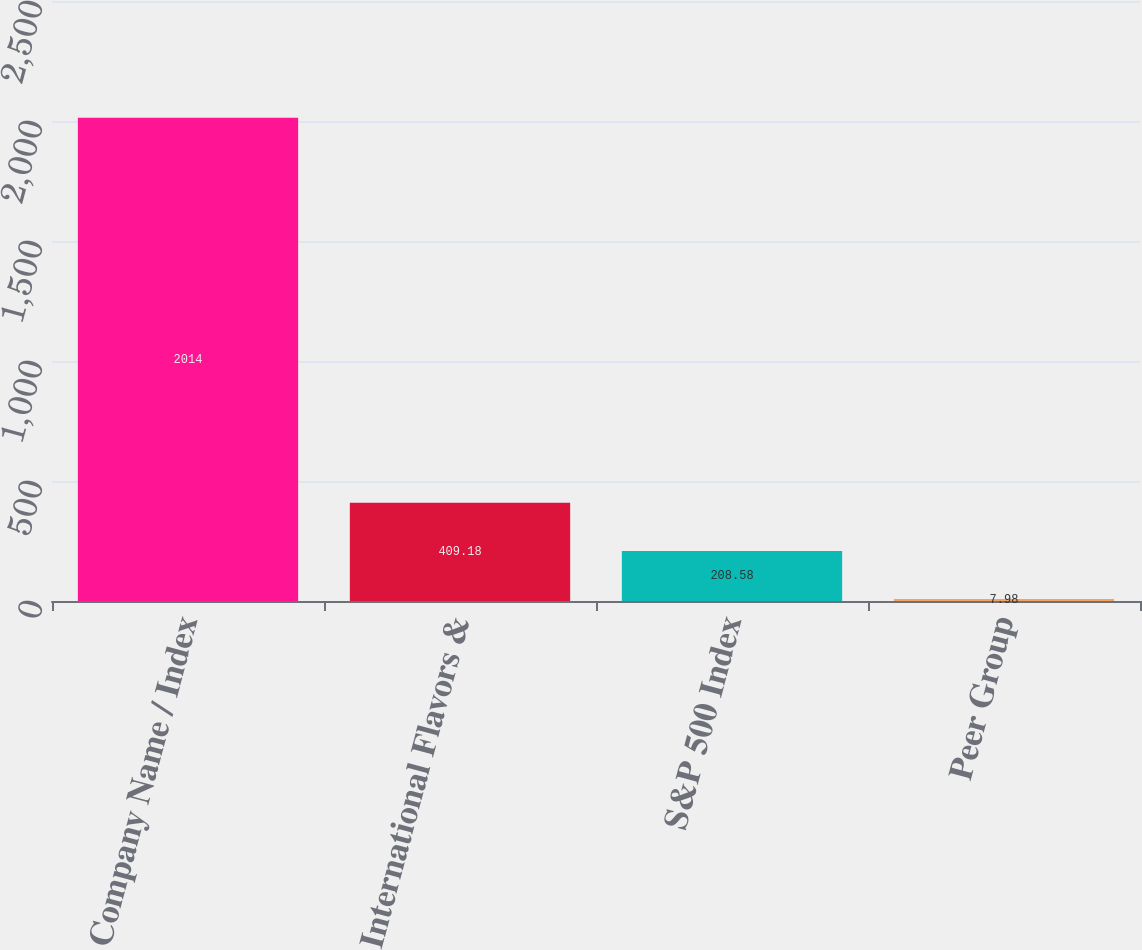<chart> <loc_0><loc_0><loc_500><loc_500><bar_chart><fcel>Company Name / Index<fcel>International Flavors &<fcel>S&P 500 Index<fcel>Peer Group<nl><fcel>2014<fcel>409.18<fcel>208.58<fcel>7.98<nl></chart> 